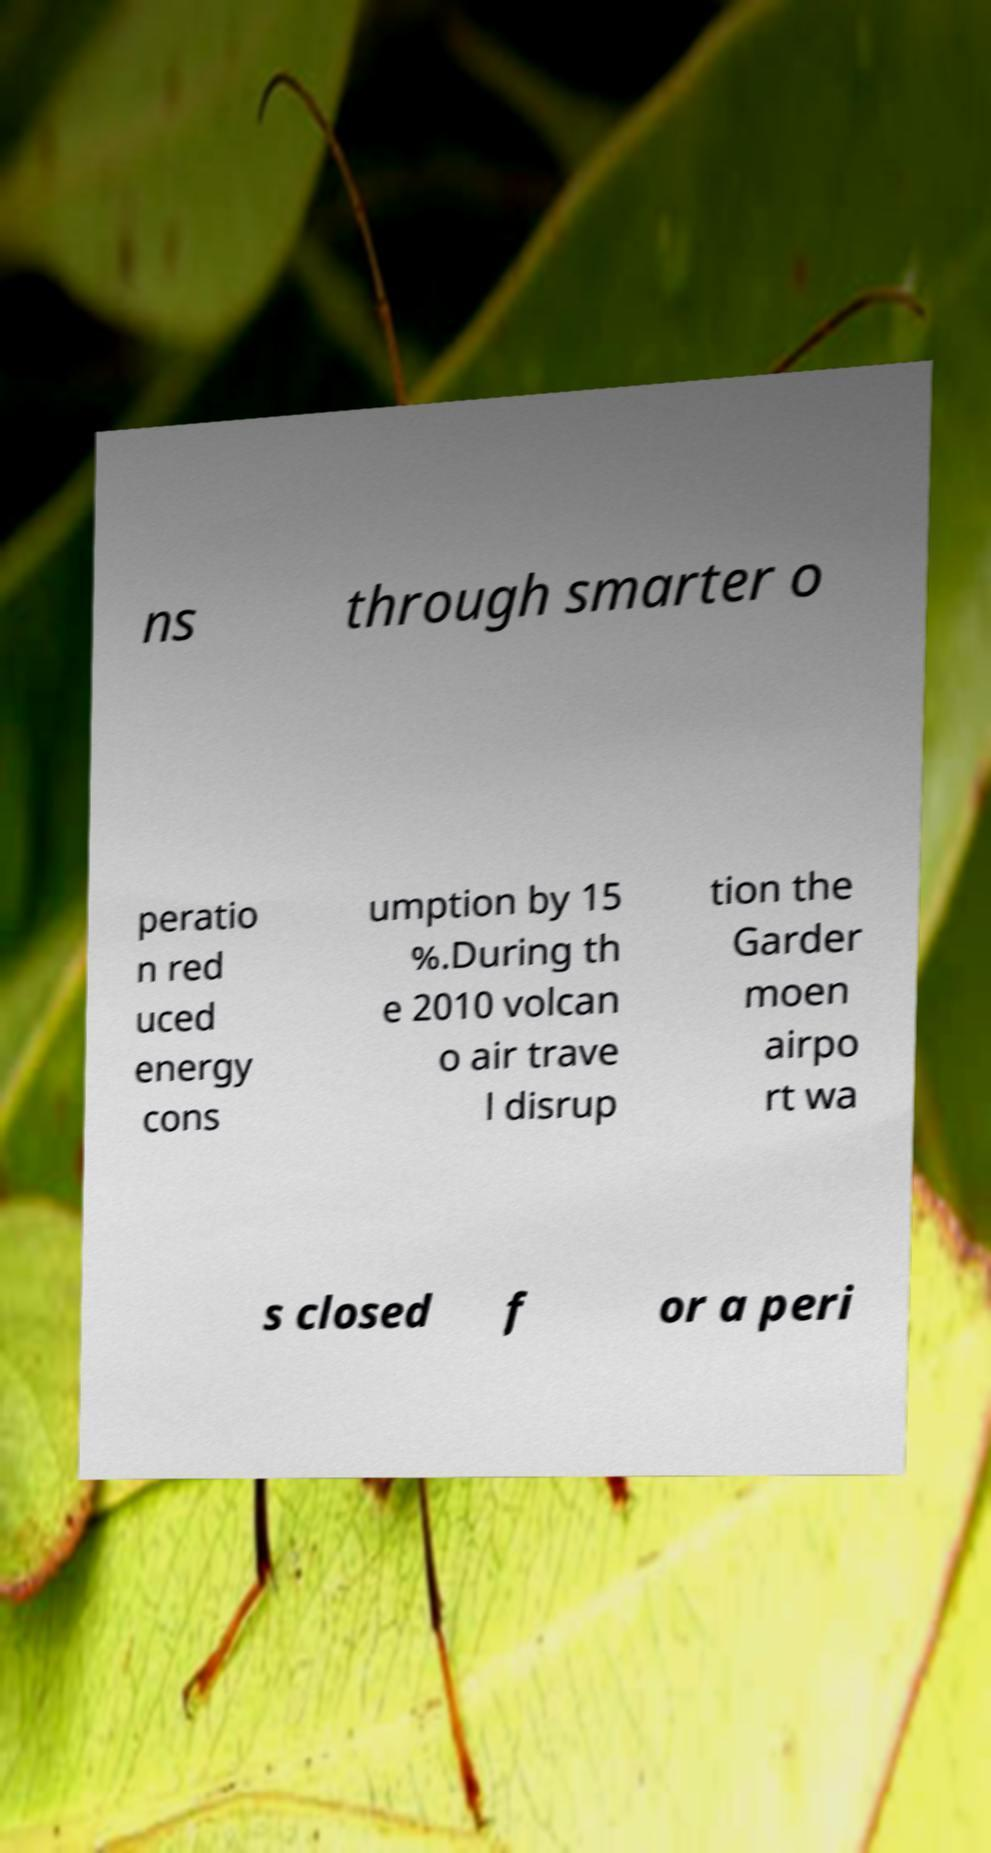There's text embedded in this image that I need extracted. Can you transcribe it verbatim? ns through smarter o peratio n red uced energy cons umption by 15 %.During th e 2010 volcan o air trave l disrup tion the Garder moen airpo rt wa s closed f or a peri 